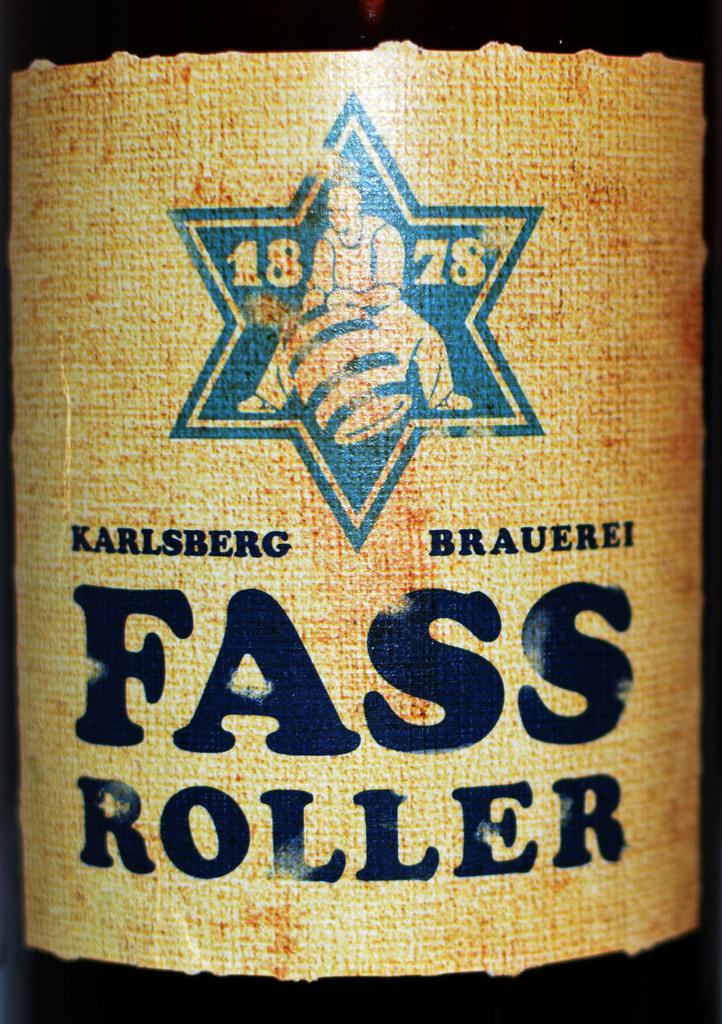<image>
Describe the image concisely. A close up of the label of a botle of 1878 Karlsberg Fass Roller. 